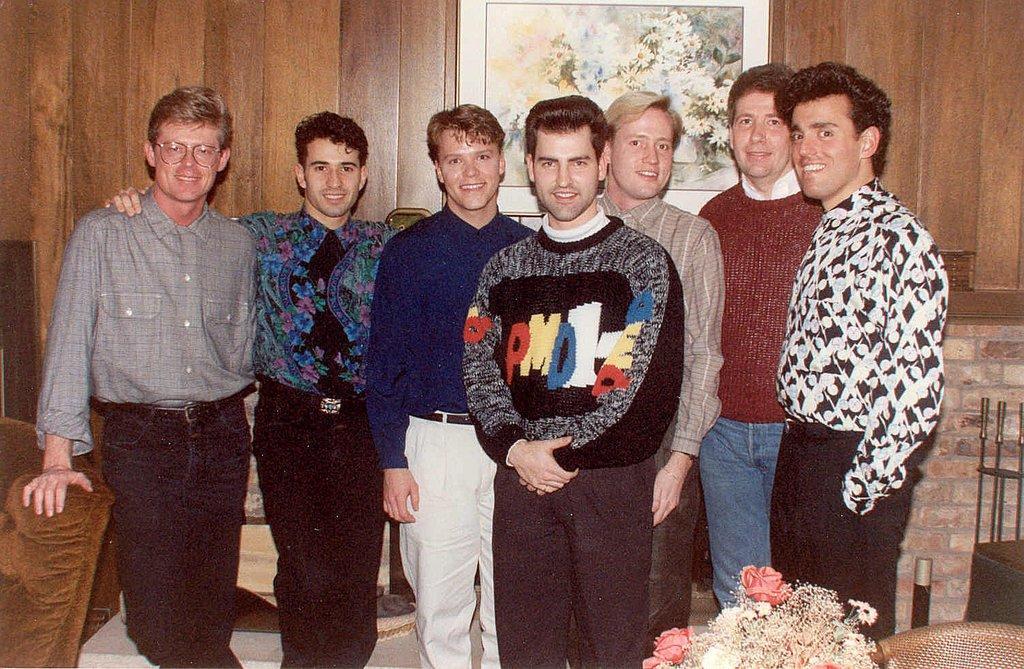Please provide a concise description of this image. In this picture I can observe some men standing on the floor. All of them are smiling. In front of them there is a bouquet. On the left side I can observe a sofa. In the background there is a photo frame fixed to the wall. The wall is in brown color. 